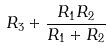<formula> <loc_0><loc_0><loc_500><loc_500>R _ { 3 } + \frac { R _ { 1 } R _ { 2 } } { R _ { 1 } + R _ { 2 } }</formula> 